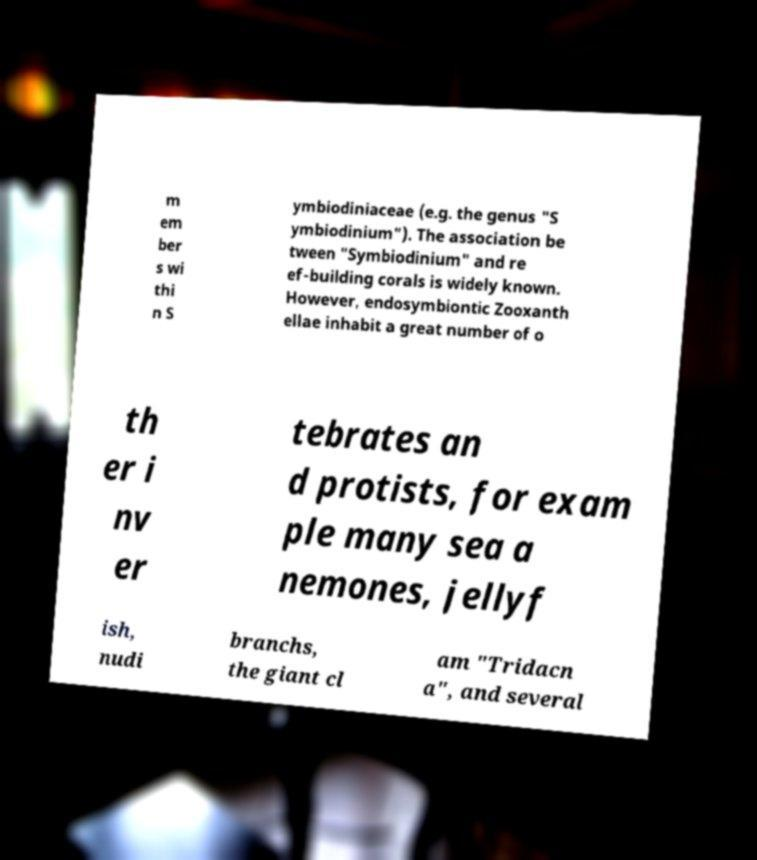For documentation purposes, I need the text within this image transcribed. Could you provide that? m em ber s wi thi n S ymbiodiniaceae (e.g. the genus "S ymbiodinium"). The association be tween "Symbiodinium" and re ef-building corals is widely known. However, endosymbiontic Zooxanth ellae inhabit a great number of o th er i nv er tebrates an d protists, for exam ple many sea a nemones, jellyf ish, nudi branchs, the giant cl am "Tridacn a", and several 